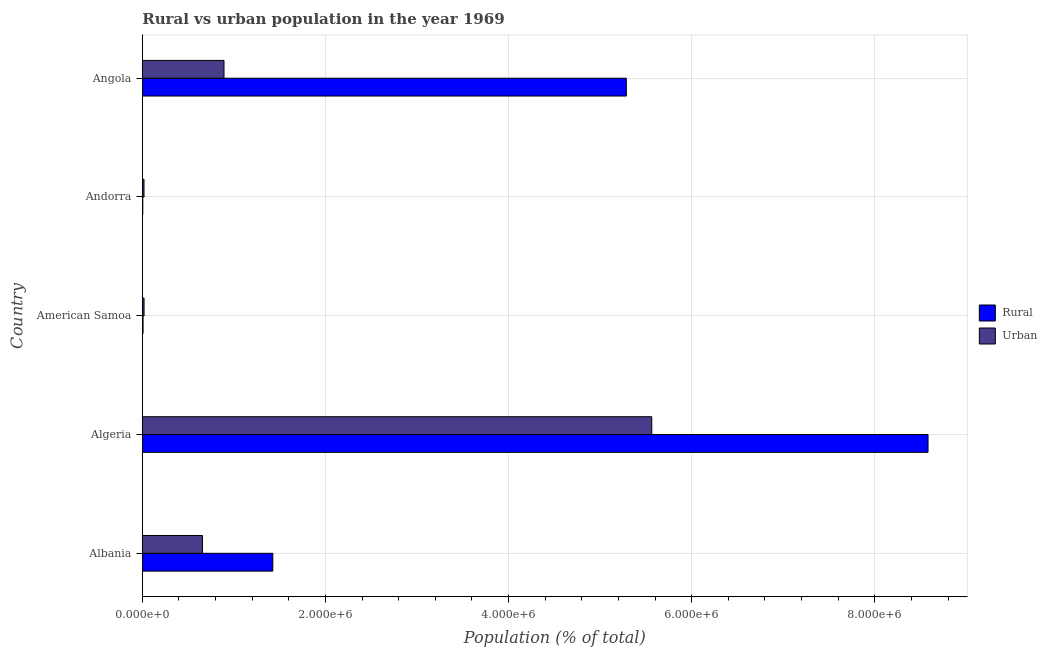Are the number of bars on each tick of the Y-axis equal?
Offer a very short reply. Yes. How many bars are there on the 2nd tick from the bottom?
Make the answer very short. 2. What is the label of the 3rd group of bars from the top?
Give a very brief answer. American Samoa. In how many cases, is the number of bars for a given country not equal to the number of legend labels?
Your answer should be very brief. 0. What is the urban population density in Algeria?
Make the answer very short. 5.56e+06. Across all countries, what is the maximum rural population density?
Your answer should be compact. 8.58e+06. Across all countries, what is the minimum rural population density?
Give a very brief answer. 4976. In which country was the rural population density maximum?
Ensure brevity in your answer.  Algeria. In which country was the rural population density minimum?
Offer a very short reply. Andorra. What is the total rural population density in the graph?
Make the answer very short. 1.53e+07. What is the difference between the rural population density in Albania and that in Andorra?
Give a very brief answer. 1.42e+06. What is the difference between the urban population density in Andorra and the rural population density in Algeria?
Make the answer very short. -8.56e+06. What is the average urban population density per country?
Offer a very short reply. 1.43e+06. What is the difference between the urban population density and rural population density in Albania?
Offer a very short reply. -7.68e+05. In how many countries, is the rural population density greater than 7200000 %?
Ensure brevity in your answer.  1. Is the urban population density in Algeria less than that in American Samoa?
Provide a succinct answer. No. What is the difference between the highest and the second highest urban population density?
Keep it short and to the point. 4.67e+06. What is the difference between the highest and the lowest rural population density?
Give a very brief answer. 8.58e+06. In how many countries, is the urban population density greater than the average urban population density taken over all countries?
Offer a very short reply. 1. What does the 2nd bar from the top in Angola represents?
Make the answer very short. Rural. What does the 1st bar from the bottom in Angola represents?
Offer a very short reply. Rural. Are all the bars in the graph horizontal?
Keep it short and to the point. Yes. What is the difference between two consecutive major ticks on the X-axis?
Ensure brevity in your answer.  2.00e+06. Does the graph contain grids?
Your response must be concise. Yes. How many legend labels are there?
Provide a succinct answer. 2. How are the legend labels stacked?
Ensure brevity in your answer.  Vertical. What is the title of the graph?
Offer a very short reply. Rural vs urban population in the year 1969. Does "Residents" appear as one of the legend labels in the graph?
Keep it short and to the point. No. What is the label or title of the X-axis?
Your answer should be compact. Population (% of total). What is the Population (% of total) in Rural in Albania?
Ensure brevity in your answer.  1.42e+06. What is the Population (% of total) of Urban in Albania?
Offer a terse response. 6.57e+05. What is the Population (% of total) in Rural in Algeria?
Your answer should be compact. 8.58e+06. What is the Population (% of total) of Urban in Algeria?
Provide a short and direct response. 5.56e+06. What is the Population (% of total) in Rural in American Samoa?
Give a very brief answer. 7990. What is the Population (% of total) in Urban in American Samoa?
Your answer should be very brief. 1.86e+04. What is the Population (% of total) in Rural in Andorra?
Keep it short and to the point. 4976. What is the Population (% of total) of Urban in Andorra?
Ensure brevity in your answer.  1.81e+04. What is the Population (% of total) of Rural in Angola?
Offer a very short reply. 5.29e+06. What is the Population (% of total) in Urban in Angola?
Your response must be concise. 8.92e+05. Across all countries, what is the maximum Population (% of total) of Rural?
Offer a terse response. 8.58e+06. Across all countries, what is the maximum Population (% of total) in Urban?
Keep it short and to the point. 5.56e+06. Across all countries, what is the minimum Population (% of total) of Rural?
Your answer should be compact. 4976. Across all countries, what is the minimum Population (% of total) in Urban?
Your answer should be very brief. 1.81e+04. What is the total Population (% of total) in Rural in the graph?
Your answer should be very brief. 1.53e+07. What is the total Population (% of total) of Urban in the graph?
Your answer should be very brief. 7.15e+06. What is the difference between the Population (% of total) of Rural in Albania and that in Algeria?
Make the answer very short. -7.16e+06. What is the difference between the Population (% of total) in Urban in Albania and that in Algeria?
Make the answer very short. -4.91e+06. What is the difference between the Population (% of total) in Rural in Albania and that in American Samoa?
Your answer should be compact. 1.42e+06. What is the difference between the Population (% of total) in Urban in Albania and that in American Samoa?
Offer a terse response. 6.38e+05. What is the difference between the Population (% of total) in Rural in Albania and that in Andorra?
Your response must be concise. 1.42e+06. What is the difference between the Population (% of total) of Urban in Albania and that in Andorra?
Ensure brevity in your answer.  6.39e+05. What is the difference between the Population (% of total) of Rural in Albania and that in Angola?
Provide a succinct answer. -3.86e+06. What is the difference between the Population (% of total) of Urban in Albania and that in Angola?
Your answer should be compact. -2.35e+05. What is the difference between the Population (% of total) in Rural in Algeria and that in American Samoa?
Make the answer very short. 8.57e+06. What is the difference between the Population (% of total) of Urban in Algeria and that in American Samoa?
Keep it short and to the point. 5.54e+06. What is the difference between the Population (% of total) in Rural in Algeria and that in Andorra?
Your answer should be compact. 8.58e+06. What is the difference between the Population (% of total) of Urban in Algeria and that in Andorra?
Your answer should be very brief. 5.55e+06. What is the difference between the Population (% of total) in Rural in Algeria and that in Angola?
Make the answer very short. 3.29e+06. What is the difference between the Population (% of total) in Urban in Algeria and that in Angola?
Give a very brief answer. 4.67e+06. What is the difference between the Population (% of total) of Rural in American Samoa and that in Andorra?
Your response must be concise. 3014. What is the difference between the Population (% of total) in Urban in American Samoa and that in Andorra?
Your response must be concise. 540. What is the difference between the Population (% of total) in Rural in American Samoa and that in Angola?
Make the answer very short. -5.28e+06. What is the difference between the Population (% of total) of Urban in American Samoa and that in Angola?
Your answer should be very brief. -8.73e+05. What is the difference between the Population (% of total) in Rural in Andorra and that in Angola?
Make the answer very short. -5.28e+06. What is the difference between the Population (% of total) of Urban in Andorra and that in Angola?
Provide a short and direct response. -8.74e+05. What is the difference between the Population (% of total) in Rural in Albania and the Population (% of total) in Urban in Algeria?
Ensure brevity in your answer.  -4.14e+06. What is the difference between the Population (% of total) of Rural in Albania and the Population (% of total) of Urban in American Samoa?
Your answer should be very brief. 1.41e+06. What is the difference between the Population (% of total) of Rural in Albania and the Population (% of total) of Urban in Andorra?
Keep it short and to the point. 1.41e+06. What is the difference between the Population (% of total) of Rural in Albania and the Population (% of total) of Urban in Angola?
Ensure brevity in your answer.  5.33e+05. What is the difference between the Population (% of total) of Rural in Algeria and the Population (% of total) of Urban in American Samoa?
Your answer should be very brief. 8.56e+06. What is the difference between the Population (% of total) in Rural in Algeria and the Population (% of total) in Urban in Andorra?
Offer a very short reply. 8.56e+06. What is the difference between the Population (% of total) in Rural in Algeria and the Population (% of total) in Urban in Angola?
Offer a very short reply. 7.69e+06. What is the difference between the Population (% of total) in Rural in American Samoa and the Population (% of total) in Urban in Andorra?
Keep it short and to the point. -1.01e+04. What is the difference between the Population (% of total) in Rural in American Samoa and the Population (% of total) in Urban in Angola?
Provide a short and direct response. -8.84e+05. What is the difference between the Population (% of total) of Rural in Andorra and the Population (% of total) of Urban in Angola?
Give a very brief answer. -8.87e+05. What is the average Population (% of total) of Rural per country?
Your answer should be very brief. 3.06e+06. What is the average Population (% of total) of Urban per country?
Your response must be concise. 1.43e+06. What is the difference between the Population (% of total) of Rural and Population (% of total) of Urban in Albania?
Keep it short and to the point. 7.68e+05. What is the difference between the Population (% of total) of Rural and Population (% of total) of Urban in Algeria?
Provide a succinct answer. 3.02e+06. What is the difference between the Population (% of total) of Rural and Population (% of total) of Urban in American Samoa?
Give a very brief answer. -1.06e+04. What is the difference between the Population (% of total) in Rural and Population (% of total) in Urban in Andorra?
Your answer should be very brief. -1.31e+04. What is the difference between the Population (% of total) in Rural and Population (% of total) in Urban in Angola?
Your response must be concise. 4.39e+06. What is the ratio of the Population (% of total) in Rural in Albania to that in Algeria?
Provide a short and direct response. 0.17. What is the ratio of the Population (% of total) of Urban in Albania to that in Algeria?
Provide a short and direct response. 0.12. What is the ratio of the Population (% of total) of Rural in Albania to that in American Samoa?
Your response must be concise. 178.34. What is the ratio of the Population (% of total) of Urban in Albania to that in American Samoa?
Your response must be concise. 35.26. What is the ratio of the Population (% of total) in Rural in Albania to that in Andorra?
Your answer should be compact. 286.37. What is the ratio of the Population (% of total) in Urban in Albania to that in Andorra?
Provide a succinct answer. 36.31. What is the ratio of the Population (% of total) of Rural in Albania to that in Angola?
Your response must be concise. 0.27. What is the ratio of the Population (% of total) of Urban in Albania to that in Angola?
Offer a terse response. 0.74. What is the ratio of the Population (% of total) in Rural in Algeria to that in American Samoa?
Your answer should be very brief. 1073.95. What is the ratio of the Population (% of total) of Urban in Algeria to that in American Samoa?
Provide a succinct answer. 298.72. What is the ratio of the Population (% of total) in Rural in Algeria to that in Andorra?
Offer a terse response. 1724.45. What is the ratio of the Population (% of total) of Urban in Algeria to that in Andorra?
Make the answer very short. 307.63. What is the ratio of the Population (% of total) in Rural in Algeria to that in Angola?
Provide a succinct answer. 1.62. What is the ratio of the Population (% of total) of Urban in Algeria to that in Angola?
Ensure brevity in your answer.  6.24. What is the ratio of the Population (% of total) in Rural in American Samoa to that in Andorra?
Your answer should be very brief. 1.61. What is the ratio of the Population (% of total) of Urban in American Samoa to that in Andorra?
Provide a short and direct response. 1.03. What is the ratio of the Population (% of total) of Rural in American Samoa to that in Angola?
Make the answer very short. 0. What is the ratio of the Population (% of total) in Urban in American Samoa to that in Angola?
Make the answer very short. 0.02. What is the ratio of the Population (% of total) of Rural in Andorra to that in Angola?
Offer a terse response. 0. What is the ratio of the Population (% of total) of Urban in Andorra to that in Angola?
Provide a succinct answer. 0.02. What is the difference between the highest and the second highest Population (% of total) in Rural?
Give a very brief answer. 3.29e+06. What is the difference between the highest and the second highest Population (% of total) of Urban?
Offer a terse response. 4.67e+06. What is the difference between the highest and the lowest Population (% of total) of Rural?
Make the answer very short. 8.58e+06. What is the difference between the highest and the lowest Population (% of total) in Urban?
Your answer should be very brief. 5.55e+06. 